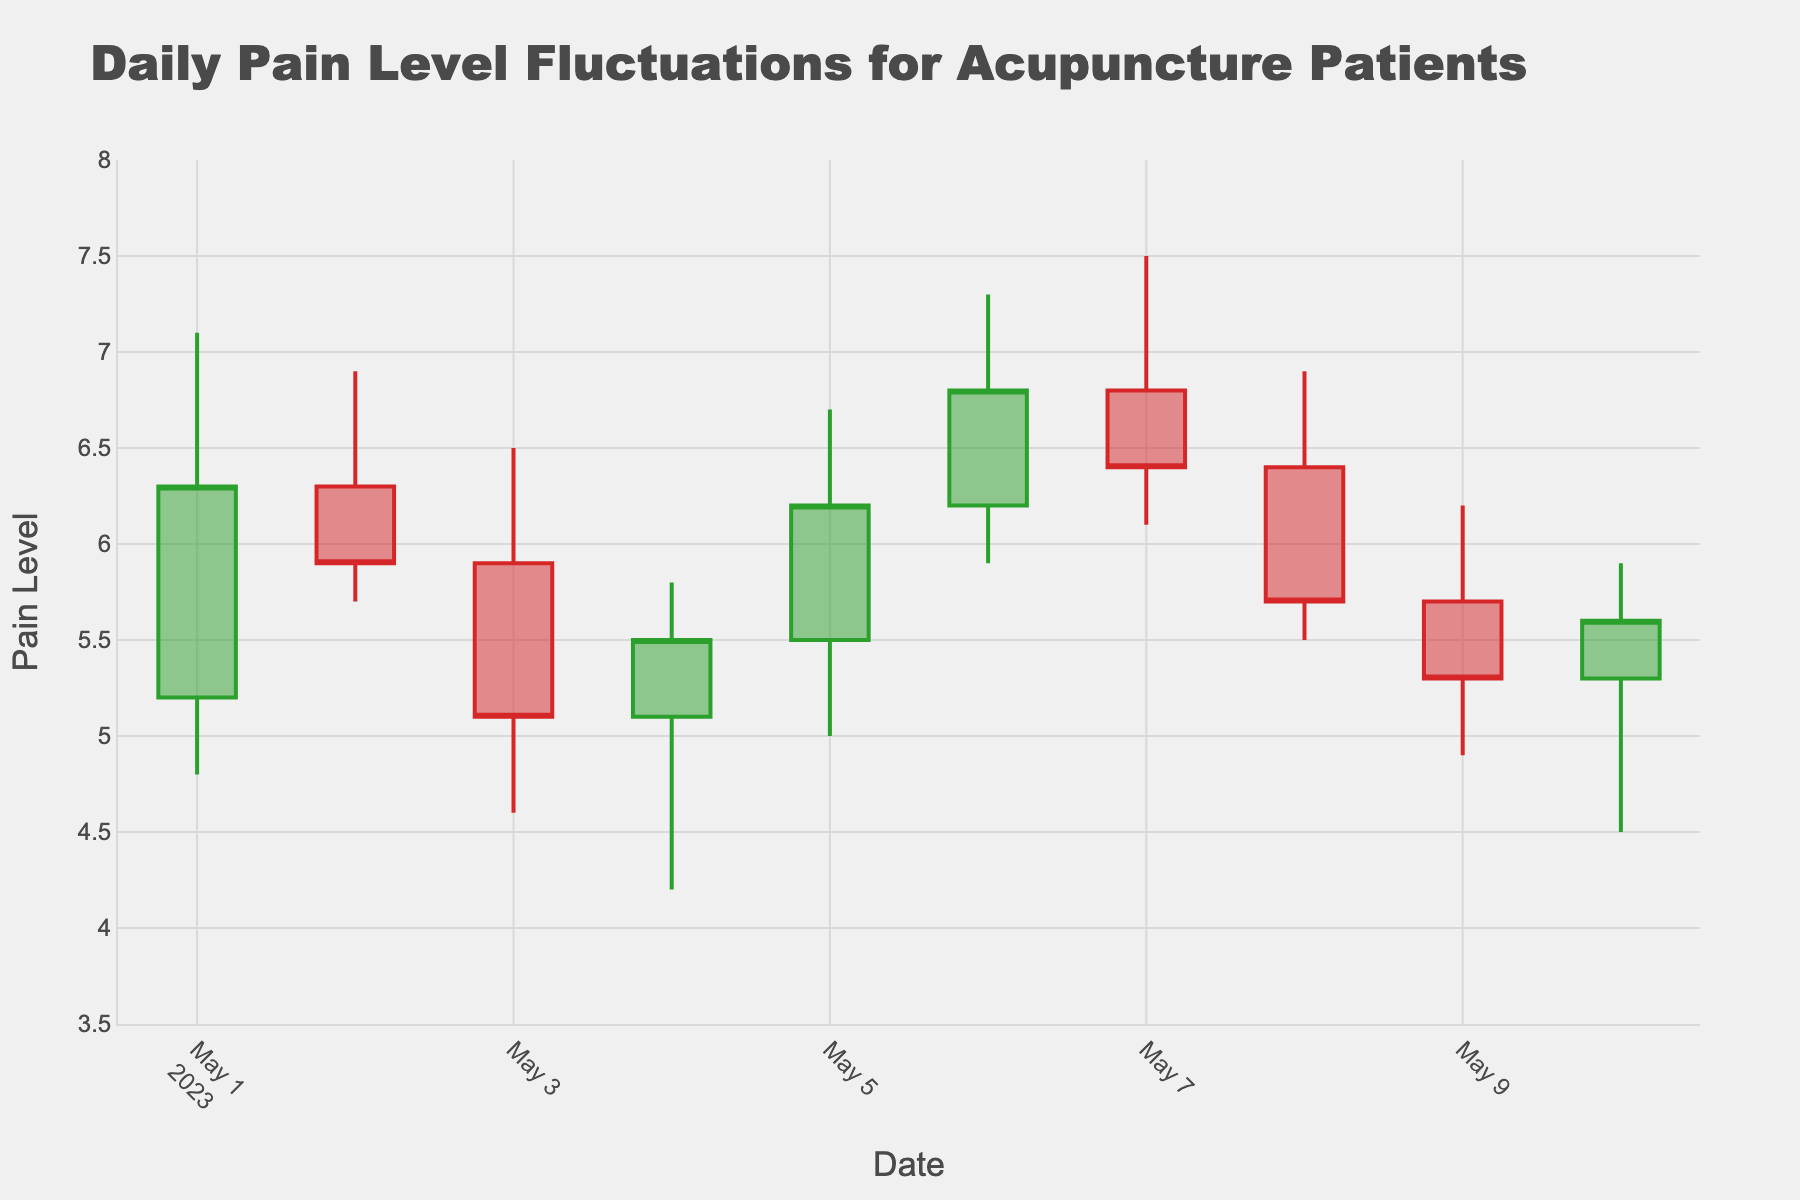What is the title of the chart? The title of the chart is displayed prominently at the top. It reads "Daily Pain Level Fluctuations for Acupuncture Patients".
Answer: Daily Pain Level Fluctuations for Acupuncture Patients What is the y-axis range for the pain levels? The y-axis shows the range of pain levels which spans from 3.5 to 8. This information can be seen on the left side of the figure where the y-axis is labeled.
Answer: 3.5 to 8 On which date did the highest pain level occur? By looking at the 'High' value of the candlesticks across the dates, we see the highest peak on 2023-05-06, where the high value reaches 7.3.
Answer: 2023-05-06 What were the opening and closing pain levels on 2023-05-04? The OHLC chart marks the opening (bottom of the body), closing (top of the body), high (upper wick), and low (lower wick). For 2023-05-04, the body's bottom is at 5.1 (Open) and its top is 5.5 (Close).
Answer: 5.1 and 5.5 How does the pain level on 2023-05-07 compare to 2023-05-06 in terms of daily low? To compare, we look at the 'Low' wick. For 2023-05-07, the low is 6.1. On 2023-05-06, the low is 5.9. Thus, the low on 2023-05-07 is higher than that on 2023-05-06.
Answer: Higher What is the average closing pain level over the first five days of the chart? The closing values for the first five days are: 6.3, 5.9, 5.1, 5.5, and 6.2. Summing these values (6.3 + 5.9 + 5.1 + 5.5 + 6.2) gives a total of 29, and dividing by 5 gives an average closing level of 5.8.
Answer: 5.8 Which days showed an increase in closing pain level compared to the previous day? We look at the 'Close' values day-by-day: 2023-05-02 (decrease from 6.3 to 5.9), 2023-05-04 (increase from 5.1 to 5.5), 2023-05-05 (increase from 5.5 to 6.2), 2023-05-06 (increase from 6.2 to 6.8), and 2023-05-10 (increase from 5.3 to 5.6). Only these four days showed an increase.
Answer: 2023-05-04, 2023-05-05, 2023-05-06, 2023-05-10 Which day has the longest range between the highest and lowest reported pain levels? The range is calculated by subtracting the 'Low' value from the 'High' value for each day. Comparing these ranges, 2023-05-06 has the longest range: 7.3 - 5.9 = 1.4.
Answer: 2023-05-06 How many days showed a downward trend in pain levels (closing lower than opening)? The 'Close' value being lower than the 'Open' value indicates a downward trend. Reviewing each day, we see May 2, May 3, May 8, and May 9 show this pattern.
Answer: 4 days 